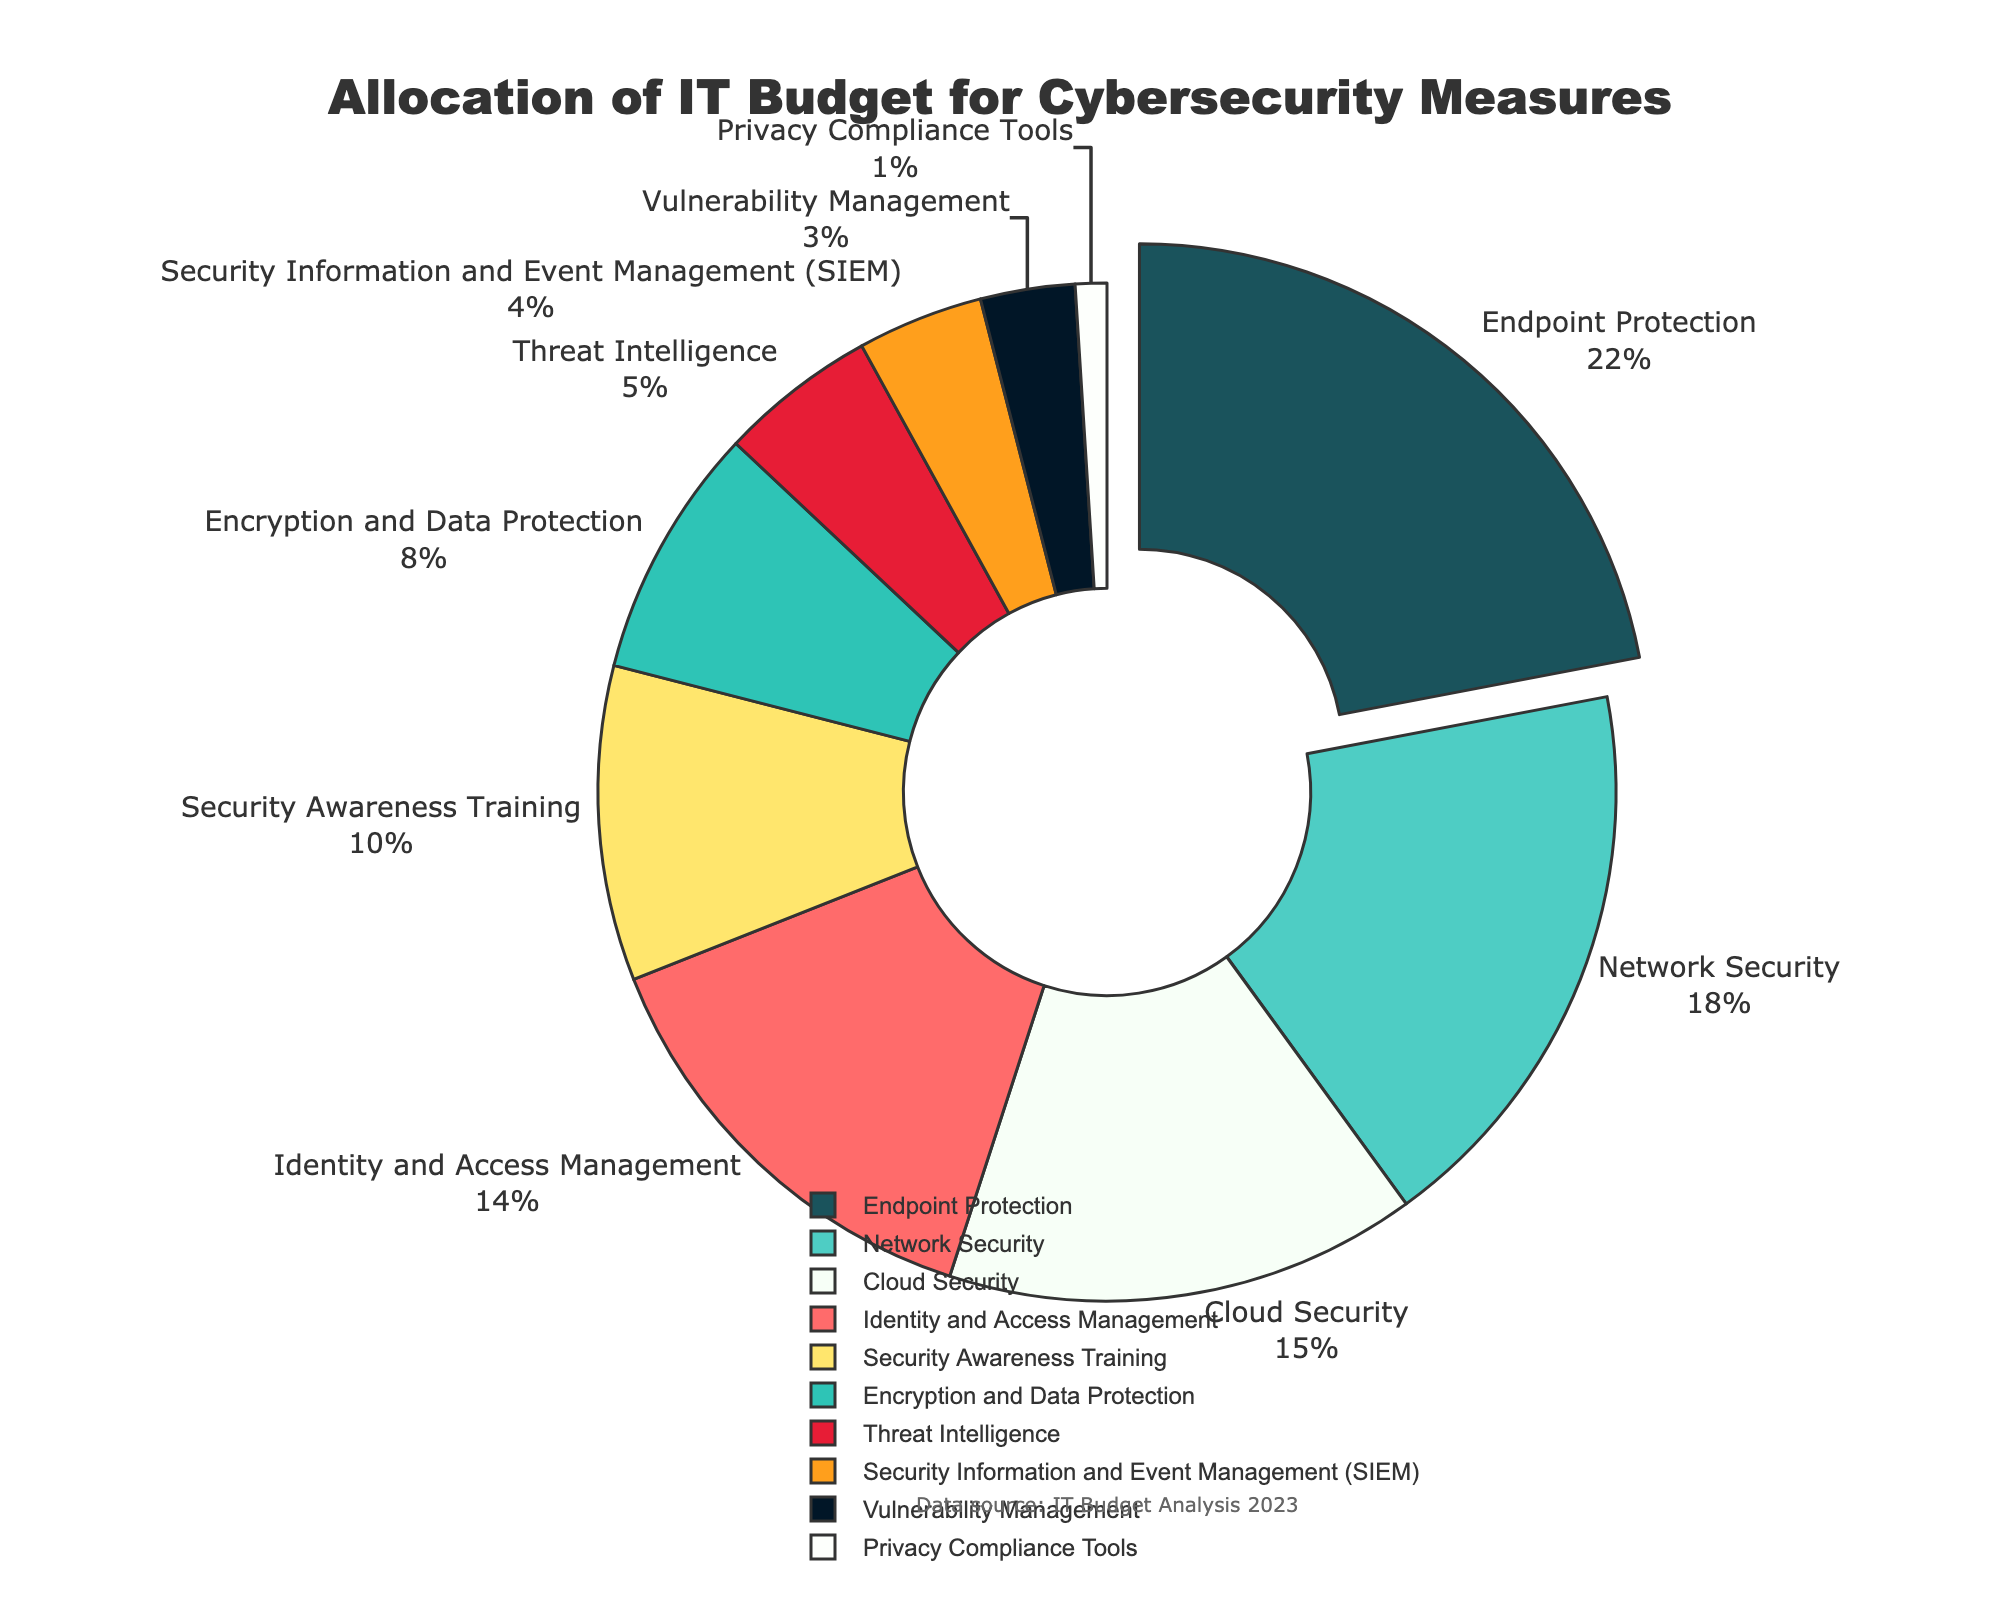Which category receives the highest allocation of the IT budget for cybersecurity measures? Endpoint Protection has the highest percentage allocation in the figure. It's visually emphasized by being pulled away from the pie.
Answer: Endpoint Protection Which category receives the lowest allocation of the IT budget for cybersecurity measures? Privacy Compliance Tools has the lowest percentage in the figure. It is the smallest segment of the pie chart.
Answer: Privacy Compliance Tools What is the combined percentage allocation for Network Security and Cloud Security? Network Security has 18% and Cloud Security has 15%. Adding them together gives 18% + 15% = 33%.
Answer: 33% How much more is allocated to Endpoint Protection compared to Identity and Access Management? Endpoint Protection has 22%, and Identity and Access Management has 14%. The difference is 22% - 14% = 8%.
Answer: 8% Compare the allocations of Security Awareness Training and Encryption and Data Protection. Which one has a higher allocation and by how much? Security Awareness Training has 10%, and Encryption and Data Protection has 8%. The difference is 10% - 8% = 2%.
Answer: Security Awareness Training by 2% What proportion of the IT budget is allocated to measures other than Endpoint Protection and Network Security? The total percentage for Endpoint Protection and Network Security is 22% + 18% = 40%. The remainder is 100% - 40% = 60%.
Answer: 60% How much larger is the allocation for Threat Intelligence compared to Vulnerability Management? Threat Intelligence has 5%, and Vulnerability Management has 3%. The difference is 5% - 3% = 2%.
Answer: 2% If you combine the budget for SIEM and Privacy Compliance Tools, what is their total allocation? SIEM has 4%, and Privacy Compliance Tools has 1%. Adding them together gives 4% + 1% = 5%.
Answer: 5% What is the average allocation of the IT budget for Endpoint Protection, Network Security, and Cloud Security? The total for these three categories is 22% + 18% + 15% = 55%. Dividing by 3 gives 55% / 3 ≈ 18.33%.
Answer: 18.33% Which three categories have the smallest allocations, and what is their combined percentage? The three smallest allocations are Privacy Compliance Tools (1%), Vulnerability Management (3%), and SIEM (4%). Adding them together gives 1% + 3% + 4% = 8%.
Answer: Privacy Compliance Tools, Vulnerability Management, SIEM, 8% 